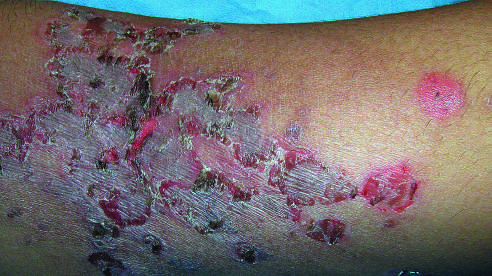how is a child 's arm involved?
Answer the question using a single word or phrase. By a superficial bacterial infection 